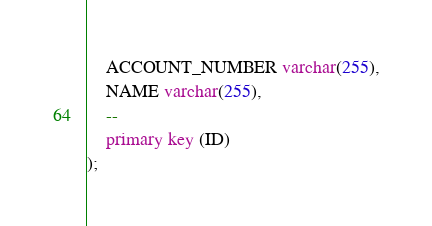Convert code to text. <code><loc_0><loc_0><loc_500><loc_500><_SQL_>    ACCOUNT_NUMBER varchar(255),
    NAME varchar(255),
    --
    primary key (ID)
);</code> 